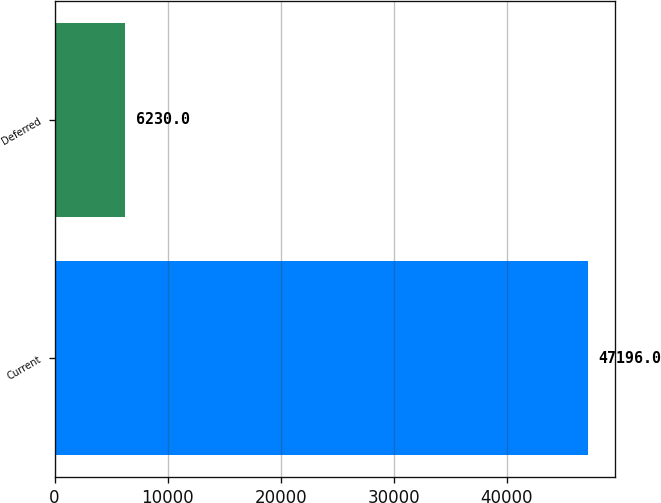<chart> <loc_0><loc_0><loc_500><loc_500><bar_chart><fcel>Current<fcel>Deferred<nl><fcel>47196<fcel>6230<nl></chart> 